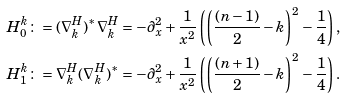<formula> <loc_0><loc_0><loc_500><loc_500>H ^ { k } _ { 0 } \colon & = ( \nabla ^ { H } _ { k } ) ^ { * } \nabla ^ { H } _ { k } = - \partial _ { x } ^ { 2 } + \frac { 1 } { x ^ { 2 } } \left ( \left ( \frac { ( n - 1 ) } { 2 } - k \right ) ^ { 2 } - \frac { 1 } { 4 } \right ) , \\ H ^ { k } _ { 1 } \colon & = \nabla ^ { H } _ { k } ( \nabla ^ { H } _ { k } ) ^ { * } = - \partial _ { x } ^ { 2 } + \frac { 1 } { x ^ { 2 } } \left ( \left ( \frac { ( n + 1 ) } { 2 } - k \right ) ^ { 2 } - \frac { 1 } { 4 } \right ) .</formula> 